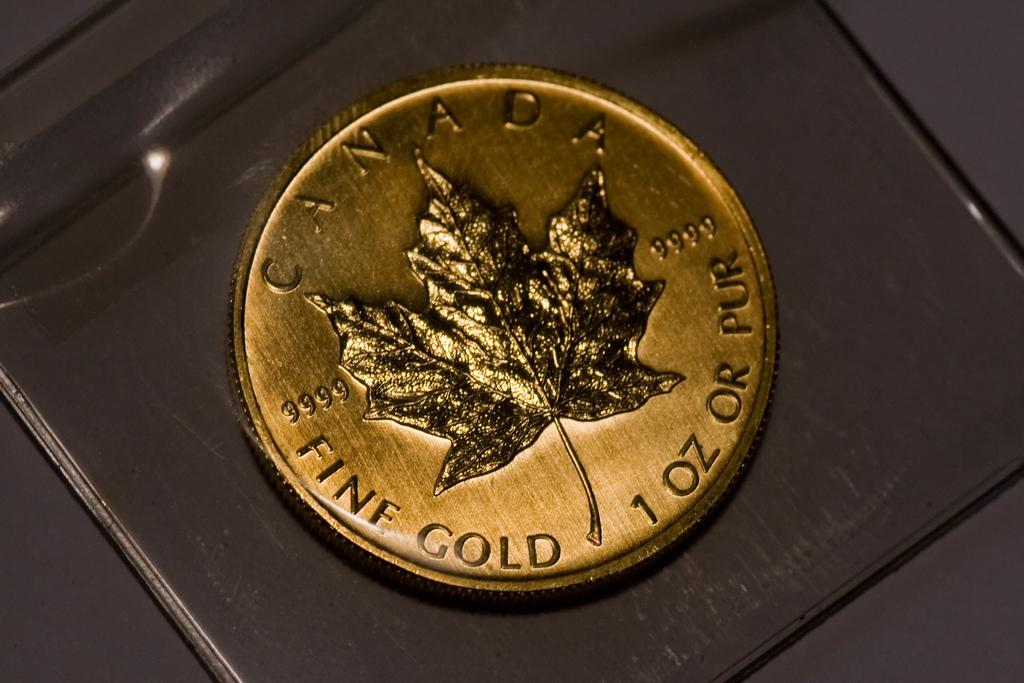What is the main subject of the image? The main subject of the image is a gold coin. What can be seen on the gold coin? There is text and a leaf depicted on the coin. What is the color of the surface on which the coin is placed? The coin is placed on a black surface. What type of needle is used to sew the fear on the home in the image? There is no needle, fear, or home present in the image; it only features a gold coin with text and a leaf. 